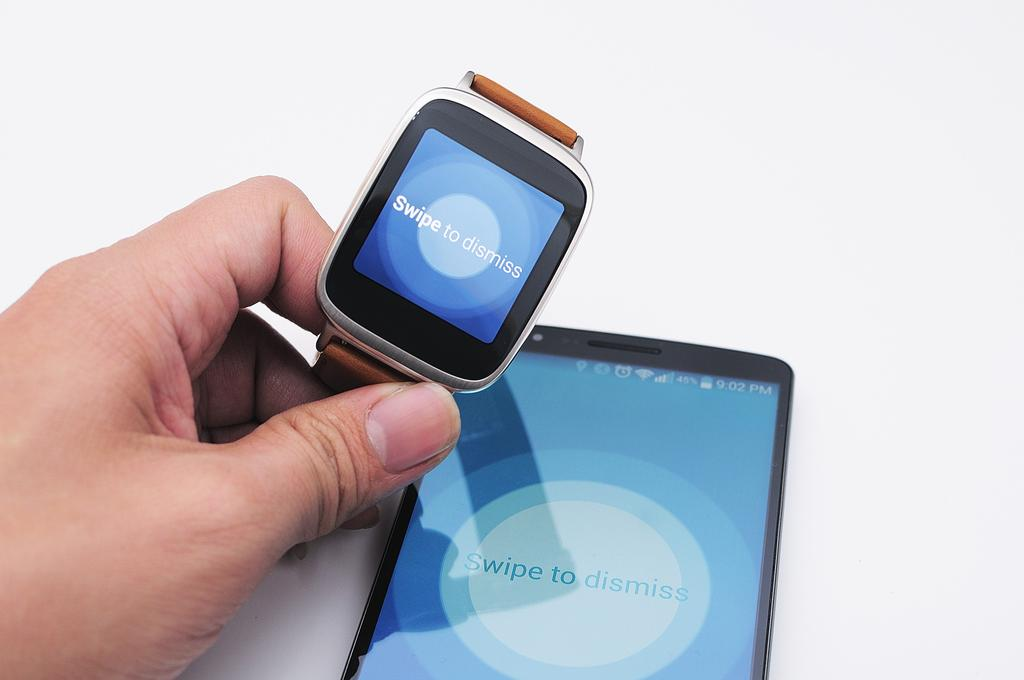<image>
Render a clear and concise summary of the photo. a smart watch and cell phone have words Swipe to Dismiss on their displays 